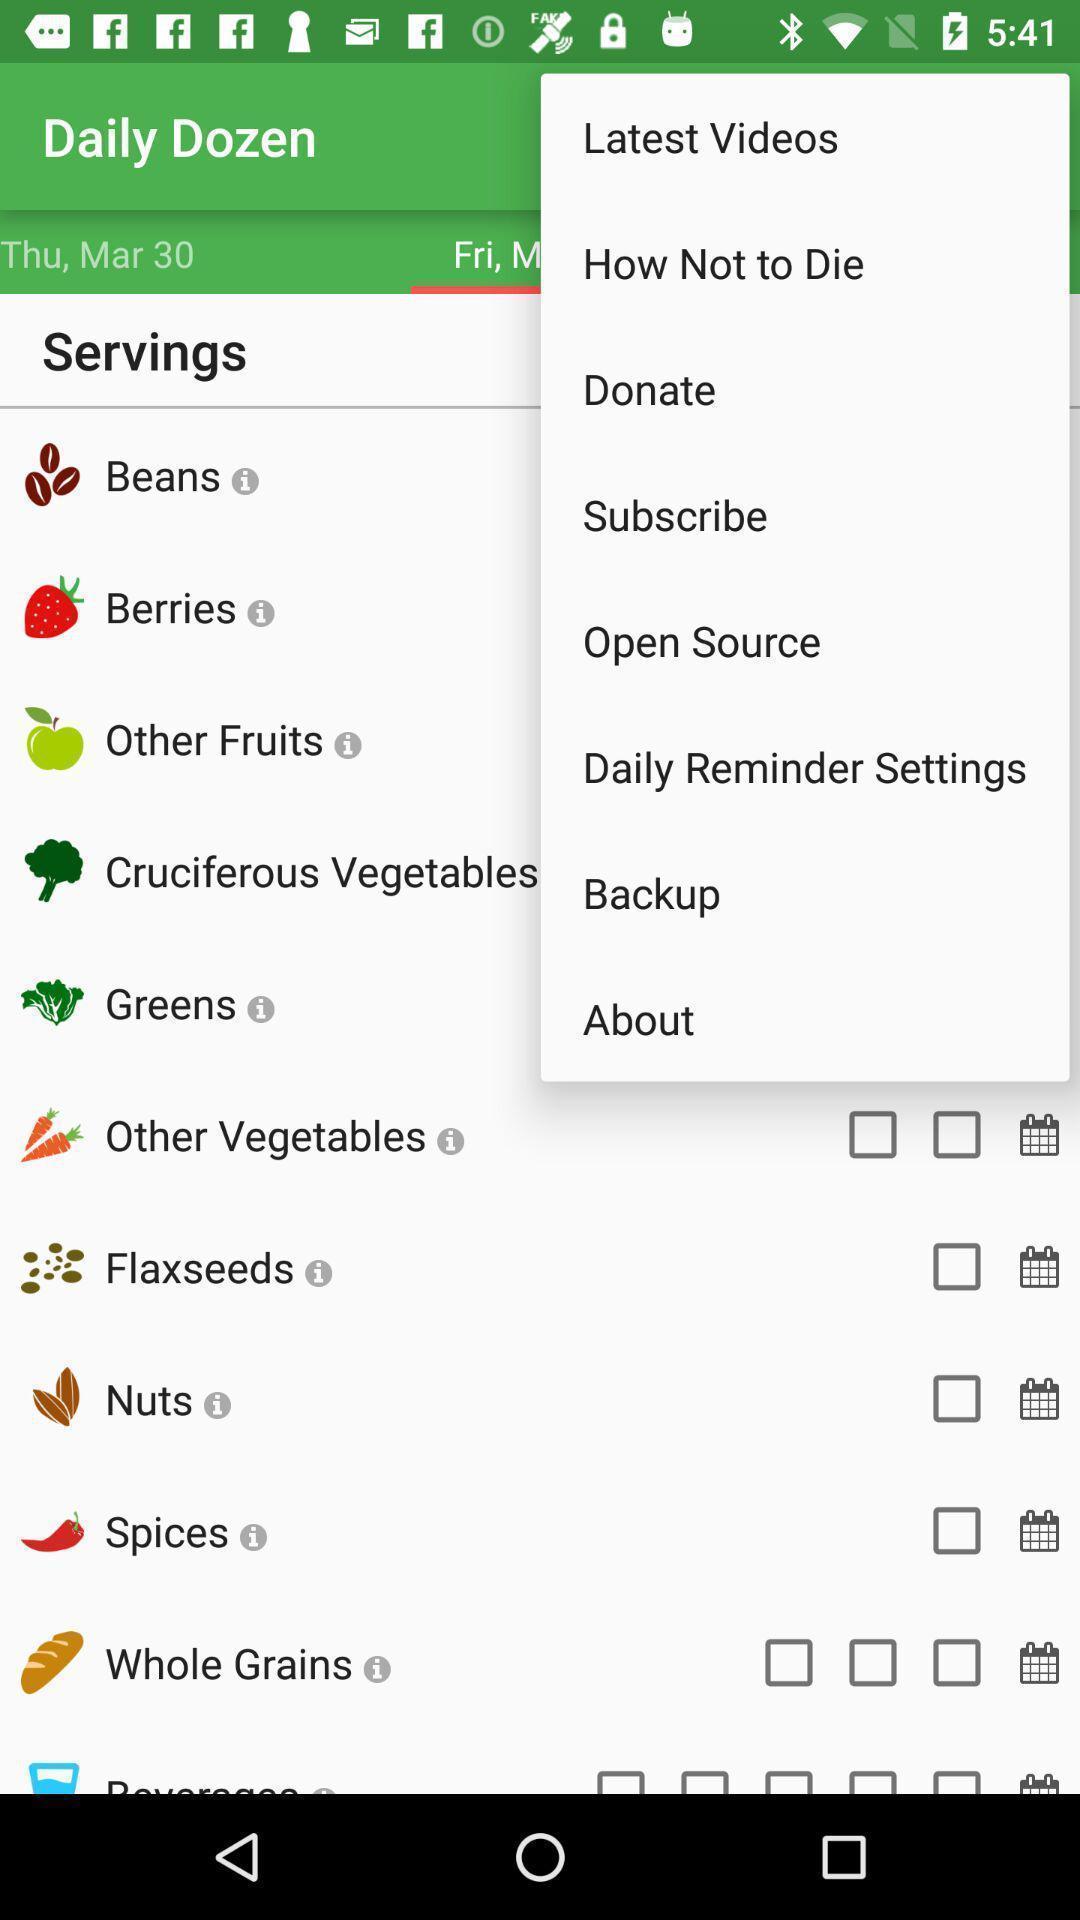Describe this image in words. Screen displaying servings page. 